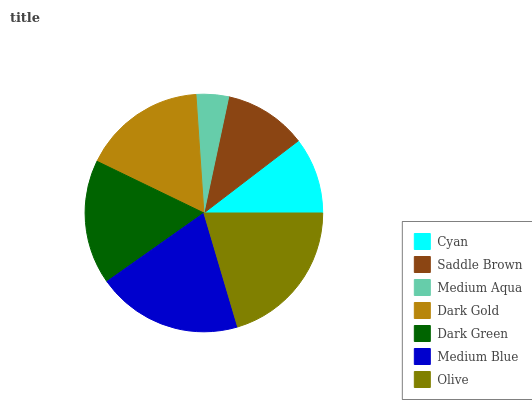Is Medium Aqua the minimum?
Answer yes or no. Yes. Is Olive the maximum?
Answer yes or no. Yes. Is Saddle Brown the minimum?
Answer yes or no. No. Is Saddle Brown the maximum?
Answer yes or no. No. Is Saddle Brown greater than Cyan?
Answer yes or no. Yes. Is Cyan less than Saddle Brown?
Answer yes or no. Yes. Is Cyan greater than Saddle Brown?
Answer yes or no. No. Is Saddle Brown less than Cyan?
Answer yes or no. No. Is Dark Gold the high median?
Answer yes or no. Yes. Is Dark Gold the low median?
Answer yes or no. Yes. Is Cyan the high median?
Answer yes or no. No. Is Saddle Brown the low median?
Answer yes or no. No. 